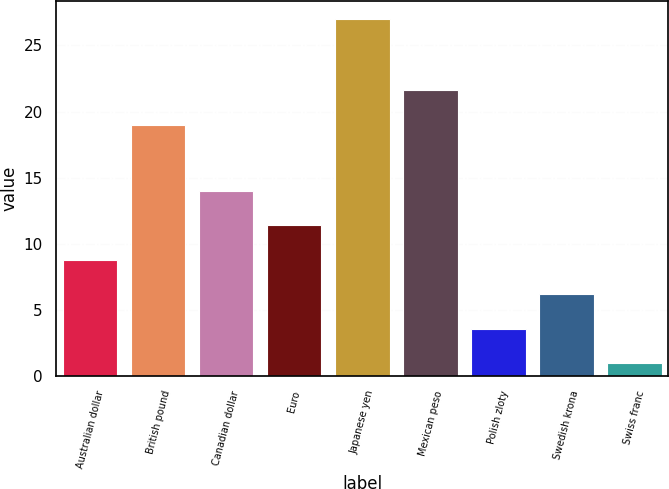Convert chart to OTSL. <chart><loc_0><loc_0><loc_500><loc_500><bar_chart><fcel>Australian dollar<fcel>British pound<fcel>Canadian dollar<fcel>Euro<fcel>Japanese yen<fcel>Mexican peso<fcel>Polish zloty<fcel>Swedish krona<fcel>Swiss franc<nl><fcel>8.8<fcel>19<fcel>14<fcel>11.4<fcel>27<fcel>21.6<fcel>3.6<fcel>6.2<fcel>1<nl></chart> 